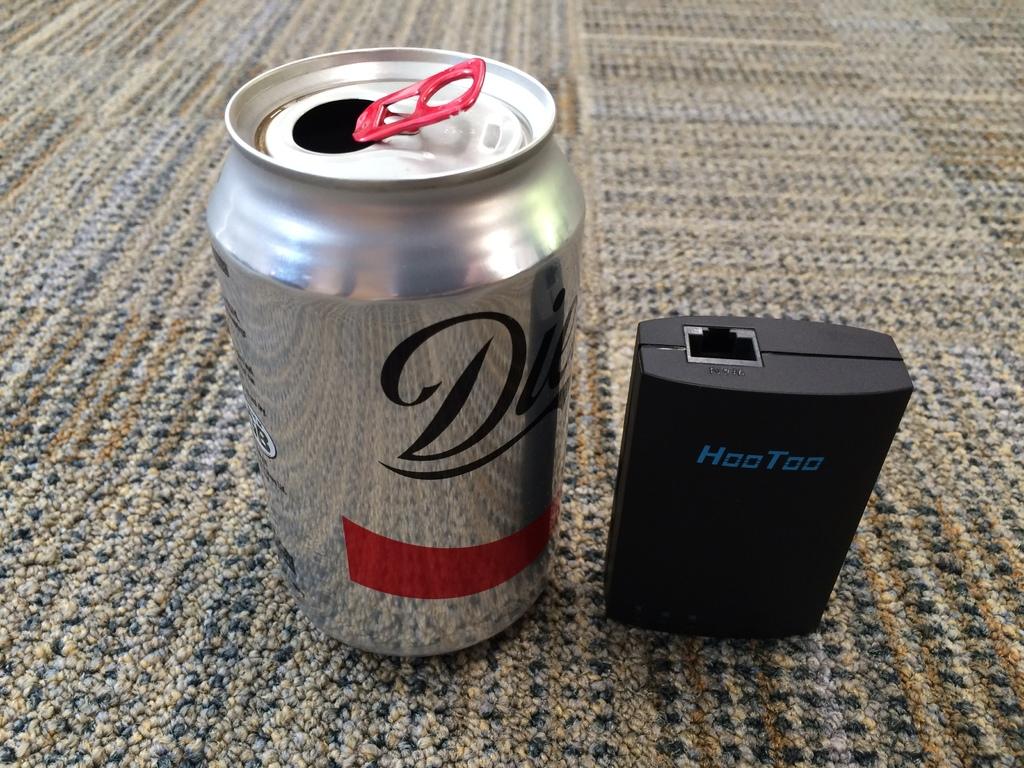What is the brand of the electronic device?
Offer a terse response. Hootoo. What brand of drink can you see?
Offer a terse response. Diet coke. 